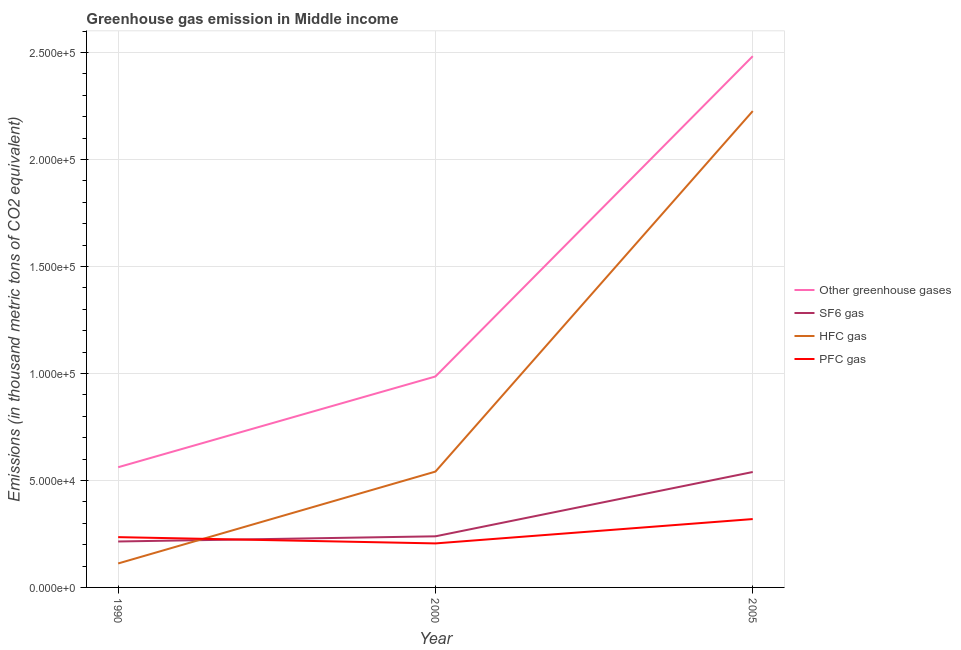Is the number of lines equal to the number of legend labels?
Provide a short and direct response. Yes. What is the emission of greenhouse gases in 2005?
Offer a terse response. 2.48e+05. Across all years, what is the maximum emission of sf6 gas?
Keep it short and to the point. 5.39e+04. Across all years, what is the minimum emission of hfc gas?
Provide a succinct answer. 1.12e+04. In which year was the emission of sf6 gas maximum?
Offer a very short reply. 2005. What is the total emission of sf6 gas in the graph?
Ensure brevity in your answer.  9.93e+04. What is the difference between the emission of sf6 gas in 2000 and that in 2005?
Give a very brief answer. -3.01e+04. What is the difference between the emission of sf6 gas in 2000 and the emission of greenhouse gases in 2005?
Ensure brevity in your answer.  -2.24e+05. What is the average emission of hfc gas per year?
Offer a terse response. 9.60e+04. In the year 2005, what is the difference between the emission of greenhouse gases and emission of sf6 gas?
Offer a terse response. 1.94e+05. In how many years, is the emission of hfc gas greater than 50000 thousand metric tons?
Offer a terse response. 2. What is the ratio of the emission of hfc gas in 1990 to that in 2000?
Give a very brief answer. 0.21. Is the difference between the emission of greenhouse gases in 2000 and 2005 greater than the difference between the emission of pfc gas in 2000 and 2005?
Keep it short and to the point. No. What is the difference between the highest and the second highest emission of sf6 gas?
Give a very brief answer. 3.01e+04. What is the difference between the highest and the lowest emission of pfc gas?
Your answer should be very brief. 1.14e+04. In how many years, is the emission of greenhouse gases greater than the average emission of greenhouse gases taken over all years?
Ensure brevity in your answer.  1. Is it the case that in every year, the sum of the emission of greenhouse gases and emission of sf6 gas is greater than the sum of emission of hfc gas and emission of pfc gas?
Offer a very short reply. Yes. Is it the case that in every year, the sum of the emission of greenhouse gases and emission of sf6 gas is greater than the emission of hfc gas?
Your answer should be very brief. Yes. Is the emission of sf6 gas strictly greater than the emission of greenhouse gases over the years?
Your answer should be compact. No. What is the difference between two consecutive major ticks on the Y-axis?
Make the answer very short. 5.00e+04. Does the graph contain any zero values?
Offer a very short reply. No. Does the graph contain grids?
Ensure brevity in your answer.  Yes. Where does the legend appear in the graph?
Give a very brief answer. Center right. What is the title of the graph?
Make the answer very short. Greenhouse gas emission in Middle income. What is the label or title of the Y-axis?
Keep it short and to the point. Emissions (in thousand metric tons of CO2 equivalent). What is the Emissions (in thousand metric tons of CO2 equivalent) in Other greenhouse gases in 1990?
Provide a succinct answer. 5.62e+04. What is the Emissions (in thousand metric tons of CO2 equivalent) in SF6 gas in 1990?
Keep it short and to the point. 2.15e+04. What is the Emissions (in thousand metric tons of CO2 equivalent) of HFC gas in 1990?
Provide a short and direct response. 1.12e+04. What is the Emissions (in thousand metric tons of CO2 equivalent) in PFC gas in 1990?
Your response must be concise. 2.35e+04. What is the Emissions (in thousand metric tons of CO2 equivalent) in Other greenhouse gases in 2000?
Your answer should be very brief. 9.86e+04. What is the Emissions (in thousand metric tons of CO2 equivalent) in SF6 gas in 2000?
Provide a short and direct response. 2.39e+04. What is the Emissions (in thousand metric tons of CO2 equivalent) in HFC gas in 2000?
Offer a terse response. 5.41e+04. What is the Emissions (in thousand metric tons of CO2 equivalent) of PFC gas in 2000?
Offer a terse response. 2.06e+04. What is the Emissions (in thousand metric tons of CO2 equivalent) in Other greenhouse gases in 2005?
Make the answer very short. 2.48e+05. What is the Emissions (in thousand metric tons of CO2 equivalent) in SF6 gas in 2005?
Ensure brevity in your answer.  5.39e+04. What is the Emissions (in thousand metric tons of CO2 equivalent) in HFC gas in 2005?
Provide a succinct answer. 2.23e+05. What is the Emissions (in thousand metric tons of CO2 equivalent) of PFC gas in 2005?
Your answer should be compact. 3.20e+04. Across all years, what is the maximum Emissions (in thousand metric tons of CO2 equivalent) in Other greenhouse gases?
Provide a succinct answer. 2.48e+05. Across all years, what is the maximum Emissions (in thousand metric tons of CO2 equivalent) in SF6 gas?
Offer a very short reply. 5.39e+04. Across all years, what is the maximum Emissions (in thousand metric tons of CO2 equivalent) in HFC gas?
Your answer should be compact. 2.23e+05. Across all years, what is the maximum Emissions (in thousand metric tons of CO2 equivalent) in PFC gas?
Your answer should be very brief. 3.20e+04. Across all years, what is the minimum Emissions (in thousand metric tons of CO2 equivalent) of Other greenhouse gases?
Provide a succinct answer. 5.62e+04. Across all years, what is the minimum Emissions (in thousand metric tons of CO2 equivalent) in SF6 gas?
Keep it short and to the point. 2.15e+04. Across all years, what is the minimum Emissions (in thousand metric tons of CO2 equivalent) in HFC gas?
Your answer should be very brief. 1.12e+04. Across all years, what is the minimum Emissions (in thousand metric tons of CO2 equivalent) of PFC gas?
Make the answer very short. 2.06e+04. What is the total Emissions (in thousand metric tons of CO2 equivalent) of Other greenhouse gases in the graph?
Offer a terse response. 4.03e+05. What is the total Emissions (in thousand metric tons of CO2 equivalent) in SF6 gas in the graph?
Give a very brief answer. 9.93e+04. What is the total Emissions (in thousand metric tons of CO2 equivalent) in HFC gas in the graph?
Make the answer very short. 2.88e+05. What is the total Emissions (in thousand metric tons of CO2 equivalent) of PFC gas in the graph?
Your response must be concise. 7.60e+04. What is the difference between the Emissions (in thousand metric tons of CO2 equivalent) in Other greenhouse gases in 1990 and that in 2000?
Offer a very short reply. -4.24e+04. What is the difference between the Emissions (in thousand metric tons of CO2 equivalent) in SF6 gas in 1990 and that in 2000?
Keep it short and to the point. -2413.4. What is the difference between the Emissions (in thousand metric tons of CO2 equivalent) of HFC gas in 1990 and that in 2000?
Your answer should be very brief. -4.29e+04. What is the difference between the Emissions (in thousand metric tons of CO2 equivalent) in PFC gas in 1990 and that in 2000?
Your answer should be compact. 2931.5. What is the difference between the Emissions (in thousand metric tons of CO2 equivalent) in Other greenhouse gases in 1990 and that in 2005?
Provide a short and direct response. -1.92e+05. What is the difference between the Emissions (in thousand metric tons of CO2 equivalent) in SF6 gas in 1990 and that in 2005?
Ensure brevity in your answer.  -3.25e+04. What is the difference between the Emissions (in thousand metric tons of CO2 equivalent) in HFC gas in 1990 and that in 2005?
Offer a terse response. -2.11e+05. What is the difference between the Emissions (in thousand metric tons of CO2 equivalent) in PFC gas in 1990 and that in 2005?
Offer a very short reply. -8451.4. What is the difference between the Emissions (in thousand metric tons of CO2 equivalent) in Other greenhouse gases in 2000 and that in 2005?
Keep it short and to the point. -1.50e+05. What is the difference between the Emissions (in thousand metric tons of CO2 equivalent) of SF6 gas in 2000 and that in 2005?
Offer a very short reply. -3.01e+04. What is the difference between the Emissions (in thousand metric tons of CO2 equivalent) in HFC gas in 2000 and that in 2005?
Give a very brief answer. -1.68e+05. What is the difference between the Emissions (in thousand metric tons of CO2 equivalent) in PFC gas in 2000 and that in 2005?
Provide a succinct answer. -1.14e+04. What is the difference between the Emissions (in thousand metric tons of CO2 equivalent) in Other greenhouse gases in 1990 and the Emissions (in thousand metric tons of CO2 equivalent) in SF6 gas in 2000?
Your answer should be compact. 3.23e+04. What is the difference between the Emissions (in thousand metric tons of CO2 equivalent) of Other greenhouse gases in 1990 and the Emissions (in thousand metric tons of CO2 equivalent) of HFC gas in 2000?
Your response must be concise. 2035.7. What is the difference between the Emissions (in thousand metric tons of CO2 equivalent) of Other greenhouse gases in 1990 and the Emissions (in thousand metric tons of CO2 equivalent) of PFC gas in 2000?
Make the answer very short. 3.56e+04. What is the difference between the Emissions (in thousand metric tons of CO2 equivalent) of SF6 gas in 1990 and the Emissions (in thousand metric tons of CO2 equivalent) of HFC gas in 2000?
Offer a terse response. -3.27e+04. What is the difference between the Emissions (in thousand metric tons of CO2 equivalent) in SF6 gas in 1990 and the Emissions (in thousand metric tons of CO2 equivalent) in PFC gas in 2000?
Provide a succinct answer. 902.9. What is the difference between the Emissions (in thousand metric tons of CO2 equivalent) of HFC gas in 1990 and the Emissions (in thousand metric tons of CO2 equivalent) of PFC gas in 2000?
Your answer should be compact. -9371.2. What is the difference between the Emissions (in thousand metric tons of CO2 equivalent) of Other greenhouse gases in 1990 and the Emissions (in thousand metric tons of CO2 equivalent) of SF6 gas in 2005?
Provide a succinct answer. 2227.28. What is the difference between the Emissions (in thousand metric tons of CO2 equivalent) in Other greenhouse gases in 1990 and the Emissions (in thousand metric tons of CO2 equivalent) in HFC gas in 2005?
Provide a short and direct response. -1.66e+05. What is the difference between the Emissions (in thousand metric tons of CO2 equivalent) of Other greenhouse gases in 1990 and the Emissions (in thousand metric tons of CO2 equivalent) of PFC gas in 2005?
Offer a terse response. 2.42e+04. What is the difference between the Emissions (in thousand metric tons of CO2 equivalent) in SF6 gas in 1990 and the Emissions (in thousand metric tons of CO2 equivalent) in HFC gas in 2005?
Give a very brief answer. -2.01e+05. What is the difference between the Emissions (in thousand metric tons of CO2 equivalent) of SF6 gas in 1990 and the Emissions (in thousand metric tons of CO2 equivalent) of PFC gas in 2005?
Keep it short and to the point. -1.05e+04. What is the difference between the Emissions (in thousand metric tons of CO2 equivalent) in HFC gas in 1990 and the Emissions (in thousand metric tons of CO2 equivalent) in PFC gas in 2005?
Ensure brevity in your answer.  -2.08e+04. What is the difference between the Emissions (in thousand metric tons of CO2 equivalent) of Other greenhouse gases in 2000 and the Emissions (in thousand metric tons of CO2 equivalent) of SF6 gas in 2005?
Offer a very short reply. 4.46e+04. What is the difference between the Emissions (in thousand metric tons of CO2 equivalent) of Other greenhouse gases in 2000 and the Emissions (in thousand metric tons of CO2 equivalent) of HFC gas in 2005?
Your response must be concise. -1.24e+05. What is the difference between the Emissions (in thousand metric tons of CO2 equivalent) of Other greenhouse gases in 2000 and the Emissions (in thousand metric tons of CO2 equivalent) of PFC gas in 2005?
Provide a short and direct response. 6.66e+04. What is the difference between the Emissions (in thousand metric tons of CO2 equivalent) in SF6 gas in 2000 and the Emissions (in thousand metric tons of CO2 equivalent) in HFC gas in 2005?
Offer a terse response. -1.99e+05. What is the difference between the Emissions (in thousand metric tons of CO2 equivalent) of SF6 gas in 2000 and the Emissions (in thousand metric tons of CO2 equivalent) of PFC gas in 2005?
Your response must be concise. -8066.6. What is the difference between the Emissions (in thousand metric tons of CO2 equivalent) of HFC gas in 2000 and the Emissions (in thousand metric tons of CO2 equivalent) of PFC gas in 2005?
Keep it short and to the point. 2.22e+04. What is the average Emissions (in thousand metric tons of CO2 equivalent) of Other greenhouse gases per year?
Your response must be concise. 1.34e+05. What is the average Emissions (in thousand metric tons of CO2 equivalent) in SF6 gas per year?
Your answer should be very brief. 3.31e+04. What is the average Emissions (in thousand metric tons of CO2 equivalent) in HFC gas per year?
Your response must be concise. 9.60e+04. What is the average Emissions (in thousand metric tons of CO2 equivalent) in PFC gas per year?
Make the answer very short. 2.53e+04. In the year 1990, what is the difference between the Emissions (in thousand metric tons of CO2 equivalent) in Other greenhouse gases and Emissions (in thousand metric tons of CO2 equivalent) in SF6 gas?
Give a very brief answer. 3.47e+04. In the year 1990, what is the difference between the Emissions (in thousand metric tons of CO2 equivalent) in Other greenhouse gases and Emissions (in thousand metric tons of CO2 equivalent) in HFC gas?
Your answer should be very brief. 4.50e+04. In the year 1990, what is the difference between the Emissions (in thousand metric tons of CO2 equivalent) of Other greenhouse gases and Emissions (in thousand metric tons of CO2 equivalent) of PFC gas?
Provide a short and direct response. 3.27e+04. In the year 1990, what is the difference between the Emissions (in thousand metric tons of CO2 equivalent) in SF6 gas and Emissions (in thousand metric tons of CO2 equivalent) in HFC gas?
Your answer should be compact. 1.03e+04. In the year 1990, what is the difference between the Emissions (in thousand metric tons of CO2 equivalent) in SF6 gas and Emissions (in thousand metric tons of CO2 equivalent) in PFC gas?
Give a very brief answer. -2028.6. In the year 1990, what is the difference between the Emissions (in thousand metric tons of CO2 equivalent) of HFC gas and Emissions (in thousand metric tons of CO2 equivalent) of PFC gas?
Ensure brevity in your answer.  -1.23e+04. In the year 2000, what is the difference between the Emissions (in thousand metric tons of CO2 equivalent) in Other greenhouse gases and Emissions (in thousand metric tons of CO2 equivalent) in SF6 gas?
Offer a very short reply. 7.47e+04. In the year 2000, what is the difference between the Emissions (in thousand metric tons of CO2 equivalent) in Other greenhouse gases and Emissions (in thousand metric tons of CO2 equivalent) in HFC gas?
Ensure brevity in your answer.  4.45e+04. In the year 2000, what is the difference between the Emissions (in thousand metric tons of CO2 equivalent) of Other greenhouse gases and Emissions (in thousand metric tons of CO2 equivalent) of PFC gas?
Give a very brief answer. 7.80e+04. In the year 2000, what is the difference between the Emissions (in thousand metric tons of CO2 equivalent) of SF6 gas and Emissions (in thousand metric tons of CO2 equivalent) of HFC gas?
Your response must be concise. -3.03e+04. In the year 2000, what is the difference between the Emissions (in thousand metric tons of CO2 equivalent) of SF6 gas and Emissions (in thousand metric tons of CO2 equivalent) of PFC gas?
Offer a terse response. 3316.3. In the year 2000, what is the difference between the Emissions (in thousand metric tons of CO2 equivalent) in HFC gas and Emissions (in thousand metric tons of CO2 equivalent) in PFC gas?
Make the answer very short. 3.36e+04. In the year 2005, what is the difference between the Emissions (in thousand metric tons of CO2 equivalent) of Other greenhouse gases and Emissions (in thousand metric tons of CO2 equivalent) of SF6 gas?
Your answer should be very brief. 1.94e+05. In the year 2005, what is the difference between the Emissions (in thousand metric tons of CO2 equivalent) of Other greenhouse gases and Emissions (in thousand metric tons of CO2 equivalent) of HFC gas?
Provide a succinct answer. 2.56e+04. In the year 2005, what is the difference between the Emissions (in thousand metric tons of CO2 equivalent) of Other greenhouse gases and Emissions (in thousand metric tons of CO2 equivalent) of PFC gas?
Offer a very short reply. 2.16e+05. In the year 2005, what is the difference between the Emissions (in thousand metric tons of CO2 equivalent) of SF6 gas and Emissions (in thousand metric tons of CO2 equivalent) of HFC gas?
Give a very brief answer. -1.69e+05. In the year 2005, what is the difference between the Emissions (in thousand metric tons of CO2 equivalent) in SF6 gas and Emissions (in thousand metric tons of CO2 equivalent) in PFC gas?
Ensure brevity in your answer.  2.20e+04. In the year 2005, what is the difference between the Emissions (in thousand metric tons of CO2 equivalent) in HFC gas and Emissions (in thousand metric tons of CO2 equivalent) in PFC gas?
Offer a terse response. 1.91e+05. What is the ratio of the Emissions (in thousand metric tons of CO2 equivalent) in Other greenhouse gases in 1990 to that in 2000?
Offer a terse response. 0.57. What is the ratio of the Emissions (in thousand metric tons of CO2 equivalent) of SF6 gas in 1990 to that in 2000?
Make the answer very short. 0.9. What is the ratio of the Emissions (in thousand metric tons of CO2 equivalent) of HFC gas in 1990 to that in 2000?
Your answer should be very brief. 0.21. What is the ratio of the Emissions (in thousand metric tons of CO2 equivalent) of PFC gas in 1990 to that in 2000?
Make the answer very short. 1.14. What is the ratio of the Emissions (in thousand metric tons of CO2 equivalent) in Other greenhouse gases in 1990 to that in 2005?
Your answer should be very brief. 0.23. What is the ratio of the Emissions (in thousand metric tons of CO2 equivalent) in SF6 gas in 1990 to that in 2005?
Give a very brief answer. 0.4. What is the ratio of the Emissions (in thousand metric tons of CO2 equivalent) of HFC gas in 1990 to that in 2005?
Provide a succinct answer. 0.05. What is the ratio of the Emissions (in thousand metric tons of CO2 equivalent) in PFC gas in 1990 to that in 2005?
Give a very brief answer. 0.74. What is the ratio of the Emissions (in thousand metric tons of CO2 equivalent) of Other greenhouse gases in 2000 to that in 2005?
Offer a very short reply. 0.4. What is the ratio of the Emissions (in thousand metric tons of CO2 equivalent) of SF6 gas in 2000 to that in 2005?
Keep it short and to the point. 0.44. What is the ratio of the Emissions (in thousand metric tons of CO2 equivalent) in HFC gas in 2000 to that in 2005?
Provide a short and direct response. 0.24. What is the ratio of the Emissions (in thousand metric tons of CO2 equivalent) of PFC gas in 2000 to that in 2005?
Give a very brief answer. 0.64. What is the difference between the highest and the second highest Emissions (in thousand metric tons of CO2 equivalent) in Other greenhouse gases?
Offer a very short reply. 1.50e+05. What is the difference between the highest and the second highest Emissions (in thousand metric tons of CO2 equivalent) in SF6 gas?
Ensure brevity in your answer.  3.01e+04. What is the difference between the highest and the second highest Emissions (in thousand metric tons of CO2 equivalent) in HFC gas?
Ensure brevity in your answer.  1.68e+05. What is the difference between the highest and the second highest Emissions (in thousand metric tons of CO2 equivalent) in PFC gas?
Your answer should be compact. 8451.4. What is the difference between the highest and the lowest Emissions (in thousand metric tons of CO2 equivalent) of Other greenhouse gases?
Provide a succinct answer. 1.92e+05. What is the difference between the highest and the lowest Emissions (in thousand metric tons of CO2 equivalent) in SF6 gas?
Ensure brevity in your answer.  3.25e+04. What is the difference between the highest and the lowest Emissions (in thousand metric tons of CO2 equivalent) in HFC gas?
Provide a succinct answer. 2.11e+05. What is the difference between the highest and the lowest Emissions (in thousand metric tons of CO2 equivalent) in PFC gas?
Your answer should be compact. 1.14e+04. 